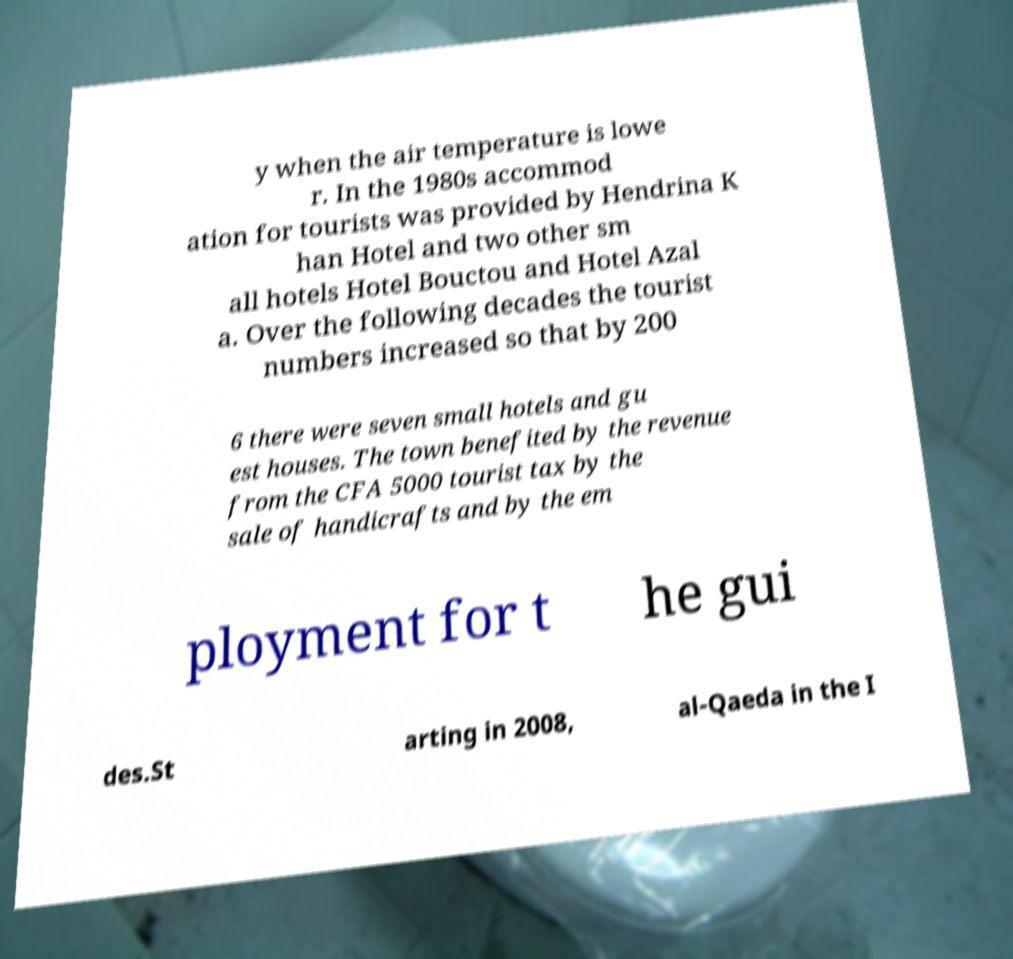Could you extract and type out the text from this image? y when the air temperature is lowe r. In the 1980s accommod ation for tourists was provided by Hendrina K han Hotel and two other sm all hotels Hotel Bouctou and Hotel Azal a. Over the following decades the tourist numbers increased so that by 200 6 there were seven small hotels and gu est houses. The town benefited by the revenue from the CFA 5000 tourist tax by the sale of handicrafts and by the em ployment for t he gui des.St arting in 2008, al-Qaeda in the I 